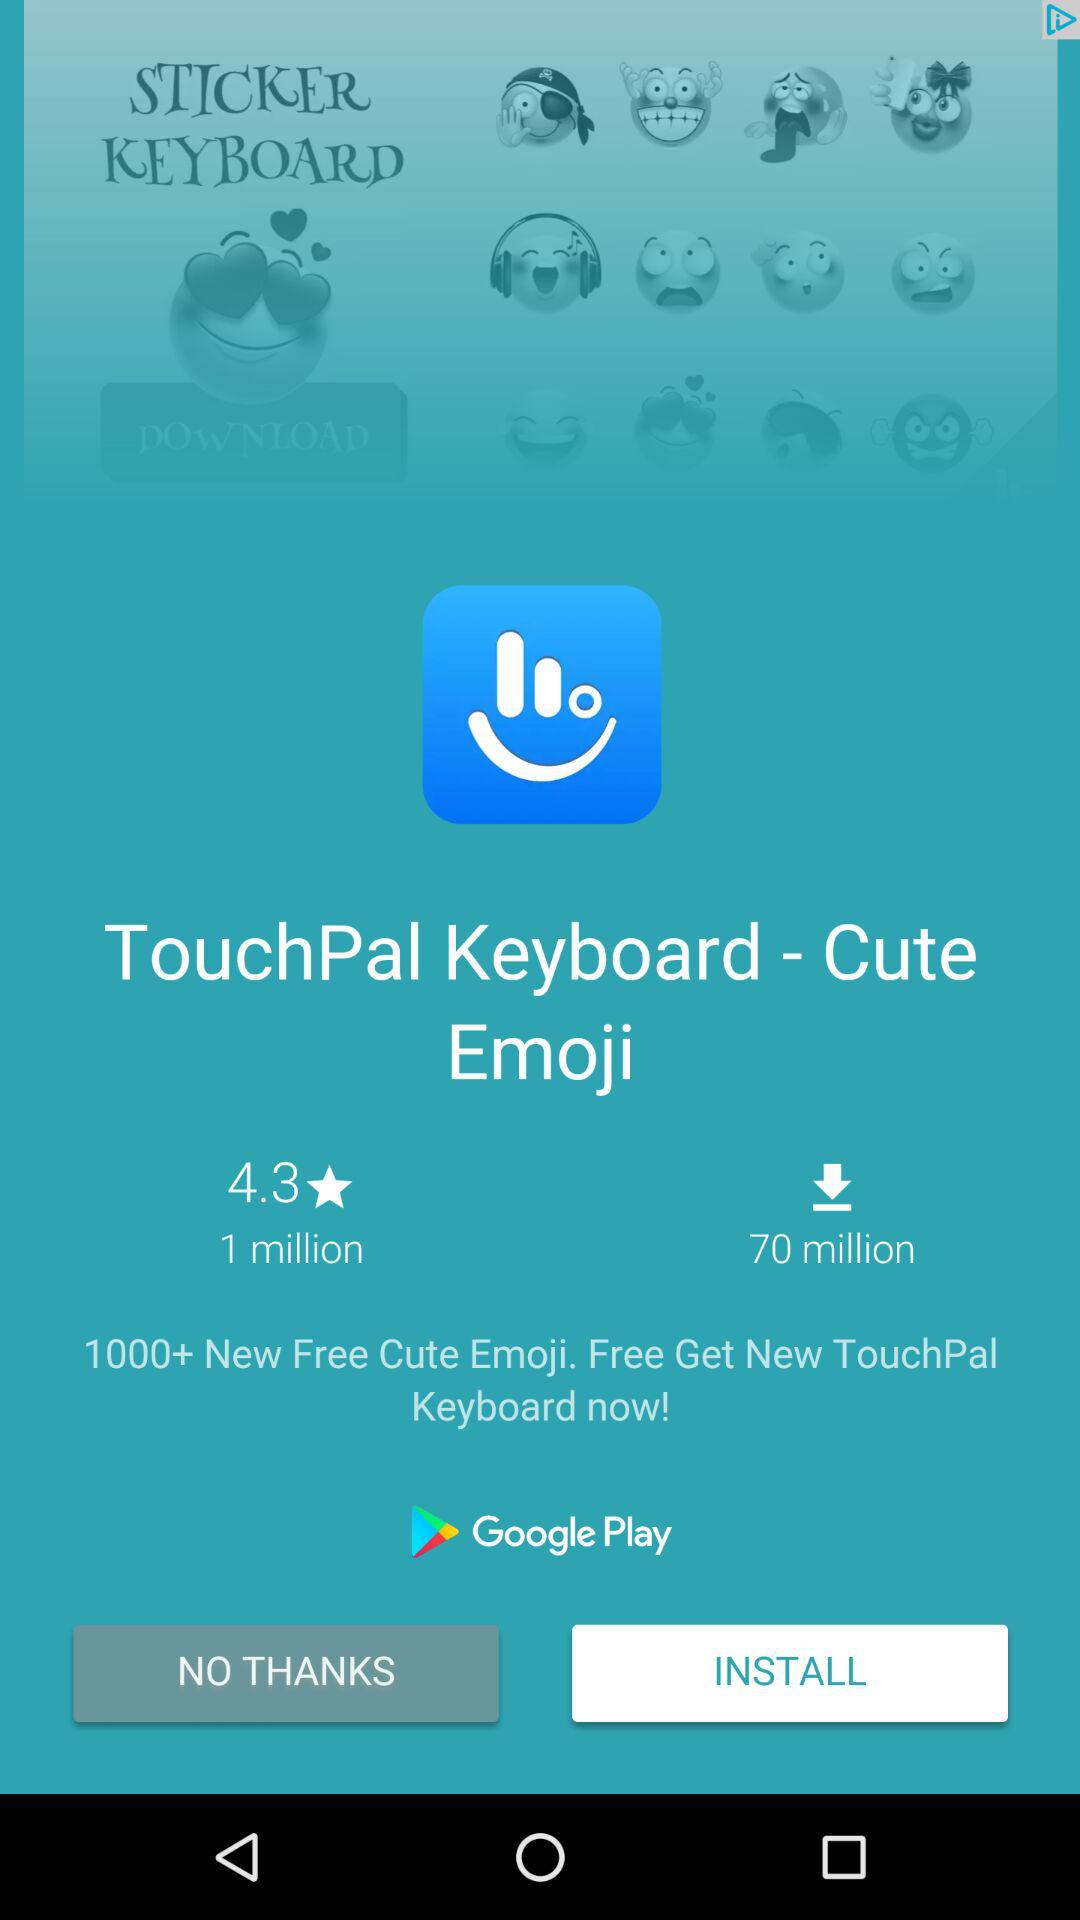How many more downloads does TouchPal Keyboard have than ratings?
Answer the question using a single word or phrase. 69 million 